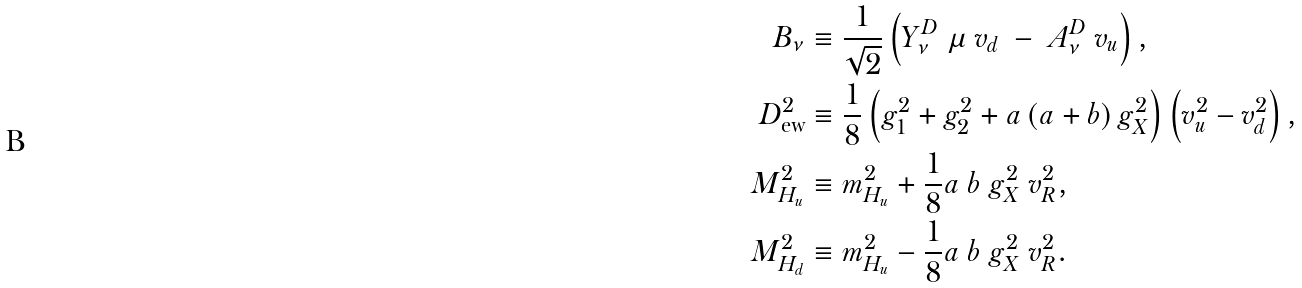<formula> <loc_0><loc_0><loc_500><loc_500>B _ { \nu } & \equiv \frac { 1 } { \sqrt { 2 } } \left ( Y _ { \nu } ^ { D } \ \mu \ v _ { d } \ - \ A _ { \nu } ^ { D } \ v _ { u } \right ) , \\ D _ { \text {ew} } ^ { 2 } & \equiv \frac { 1 } { 8 } \left ( g _ { 1 } ^ { 2 } + g _ { 2 } ^ { 2 } + a \left ( a + b \right ) g _ { X } ^ { 2 } \right ) \left ( v _ { u } ^ { 2 } - v _ { d } ^ { 2 } \right ) , \\ M _ { H _ { u } } ^ { 2 } & \equiv m _ { H _ { u } } ^ { 2 } + \frac { 1 } { 8 } a \ b \ g _ { X } ^ { 2 } \ v _ { R } ^ { 2 } , \\ M _ { H _ { d } } ^ { 2 } & \equiv m _ { H _ { u } } ^ { 2 } - \frac { 1 } { 8 } a \ b \ g _ { X } ^ { 2 } \ v _ { R } ^ { 2 } .</formula> 